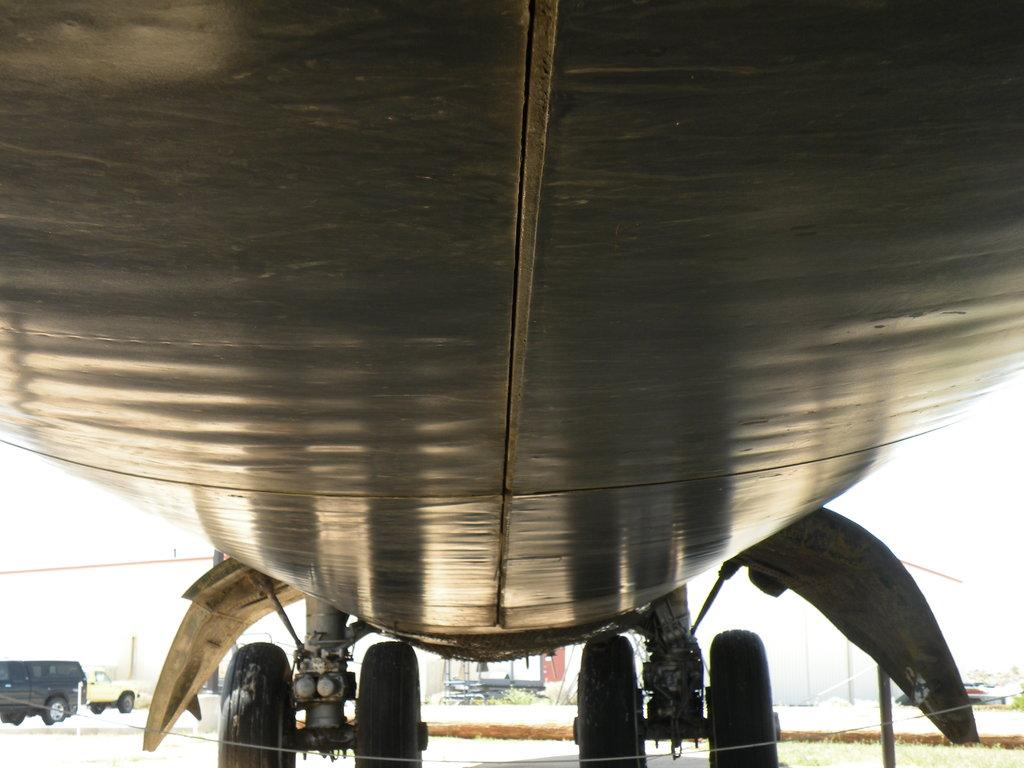What is the main subject of the image? The main subject of the image is an aircraft. How many wheels does the aircraft have on the ground? The aircraft has four wheels on the grounded on the ground. What else can be seen in the background of the image? There are two vehicles in the background of the image. What color is the background of the image? The background of the image is white in color. Can you tell me how many tomatoes are on the wall in the image? There are no tomatoes or walls present in the image; it features an aircraft with four wheels on the ground and a white background with two vehicles in the distance. 